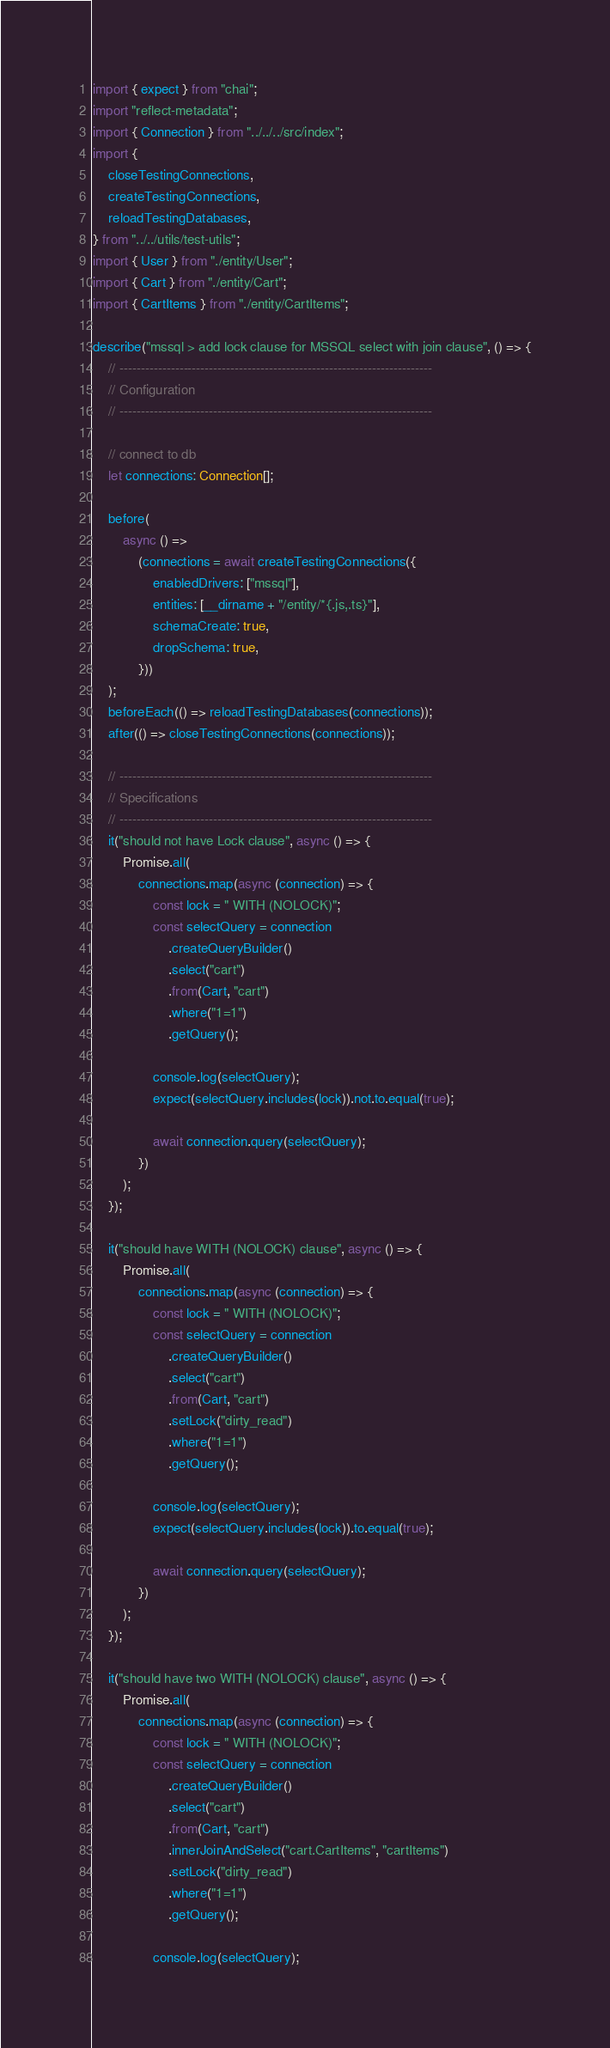Convert code to text. <code><loc_0><loc_0><loc_500><loc_500><_TypeScript_>import { expect } from "chai";
import "reflect-metadata";
import { Connection } from "../../../src/index";
import {
    closeTestingConnections,
    createTestingConnections,
    reloadTestingDatabases,
} from "../../utils/test-utils";
import { User } from "./entity/User";
import { Cart } from "./entity/Cart";
import { CartItems } from "./entity/CartItems";

describe("mssql > add lock clause for MSSQL select with join clause", () => {
    // -------------------------------------------------------------------------
    // Configuration
    // -------------------------------------------------------------------------

    // connect to db
    let connections: Connection[];

    before(
        async () =>
            (connections = await createTestingConnections({
                enabledDrivers: ["mssql"],
                entities: [__dirname + "/entity/*{.js,.ts}"],
                schemaCreate: true,
                dropSchema: true,
            }))
    );
    beforeEach(() => reloadTestingDatabases(connections));
    after(() => closeTestingConnections(connections));

    // -------------------------------------------------------------------------
    // Specifications
    // -------------------------------------------------------------------------
    it("should not have Lock clause", async () => {
        Promise.all(
            connections.map(async (connection) => {
                const lock = " WITH (NOLOCK)";
                const selectQuery = connection
                    .createQueryBuilder()
                    .select("cart")
                    .from(Cart, "cart")
                    .where("1=1")
                    .getQuery();

                console.log(selectQuery);
                expect(selectQuery.includes(lock)).not.to.equal(true);

                await connection.query(selectQuery);
            })
        );
    });

    it("should have WITH (NOLOCK) clause", async () => {
        Promise.all(
            connections.map(async (connection) => {
                const lock = " WITH (NOLOCK)";
                const selectQuery = connection
                    .createQueryBuilder()
                    .select("cart")
                    .from(Cart, "cart")
                    .setLock("dirty_read")
                    .where("1=1")
                    .getQuery();

                console.log(selectQuery);
                expect(selectQuery.includes(lock)).to.equal(true);

                await connection.query(selectQuery);
            })
        );
    });

    it("should have two WITH (NOLOCK) clause", async () => {
        Promise.all(
            connections.map(async (connection) => {
                const lock = " WITH (NOLOCK)";
                const selectQuery = connection
                    .createQueryBuilder()
                    .select("cart")
                    .from(Cart, "cart")
                    .innerJoinAndSelect("cart.CartItems", "cartItems")
                    .setLock("dirty_read")
                    .where("1=1")
                    .getQuery();

                console.log(selectQuery);</code> 